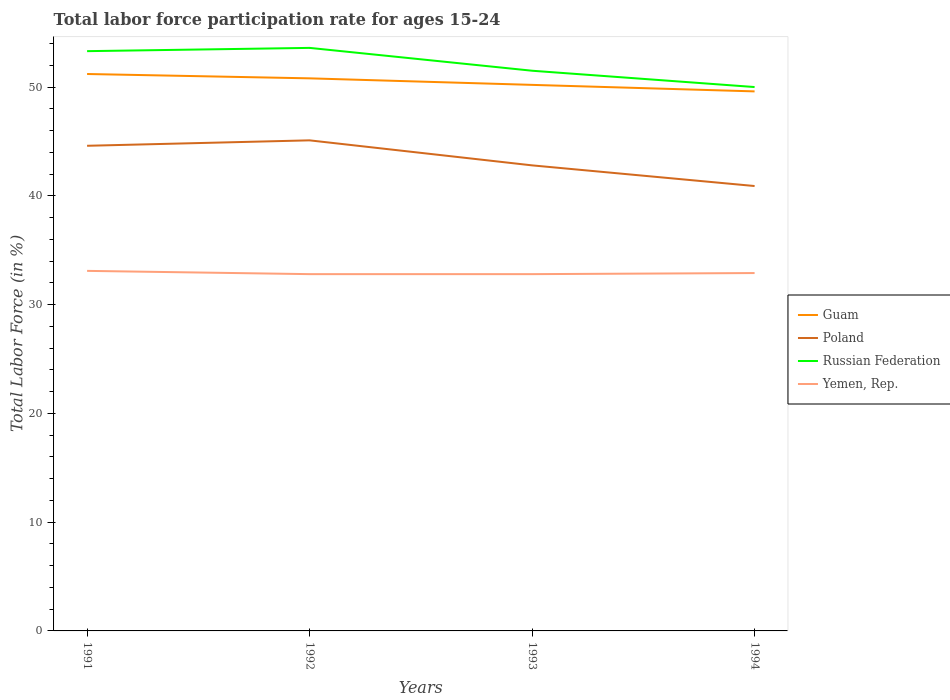How many different coloured lines are there?
Give a very brief answer. 4. Is the number of lines equal to the number of legend labels?
Your answer should be compact. Yes. Across all years, what is the maximum labor force participation rate in Poland?
Give a very brief answer. 40.9. In which year was the labor force participation rate in Russian Federation maximum?
Make the answer very short. 1994. What is the total labor force participation rate in Poland in the graph?
Make the answer very short. 1.8. What is the difference between the highest and the second highest labor force participation rate in Russian Federation?
Your answer should be compact. 3.6. Is the labor force participation rate in Guam strictly greater than the labor force participation rate in Russian Federation over the years?
Ensure brevity in your answer.  Yes. How many lines are there?
Provide a short and direct response. 4. Does the graph contain grids?
Ensure brevity in your answer.  No. How many legend labels are there?
Provide a short and direct response. 4. How are the legend labels stacked?
Keep it short and to the point. Vertical. What is the title of the graph?
Give a very brief answer. Total labor force participation rate for ages 15-24. Does "Latin America(developing only)" appear as one of the legend labels in the graph?
Keep it short and to the point. No. What is the label or title of the X-axis?
Give a very brief answer. Years. What is the label or title of the Y-axis?
Your answer should be compact. Total Labor Force (in %). What is the Total Labor Force (in %) of Guam in 1991?
Offer a very short reply. 51.2. What is the Total Labor Force (in %) in Poland in 1991?
Provide a succinct answer. 44.6. What is the Total Labor Force (in %) in Russian Federation in 1991?
Ensure brevity in your answer.  53.3. What is the Total Labor Force (in %) of Yemen, Rep. in 1991?
Ensure brevity in your answer.  33.1. What is the Total Labor Force (in %) in Guam in 1992?
Your answer should be compact. 50.8. What is the Total Labor Force (in %) in Poland in 1992?
Ensure brevity in your answer.  45.1. What is the Total Labor Force (in %) in Russian Federation in 1992?
Your answer should be very brief. 53.6. What is the Total Labor Force (in %) in Yemen, Rep. in 1992?
Ensure brevity in your answer.  32.8. What is the Total Labor Force (in %) of Guam in 1993?
Offer a very short reply. 50.2. What is the Total Labor Force (in %) in Poland in 1993?
Give a very brief answer. 42.8. What is the Total Labor Force (in %) of Russian Federation in 1993?
Keep it short and to the point. 51.5. What is the Total Labor Force (in %) of Yemen, Rep. in 1993?
Ensure brevity in your answer.  32.8. What is the Total Labor Force (in %) in Guam in 1994?
Offer a very short reply. 49.6. What is the Total Labor Force (in %) of Poland in 1994?
Provide a succinct answer. 40.9. What is the Total Labor Force (in %) in Russian Federation in 1994?
Your answer should be compact. 50. What is the Total Labor Force (in %) of Yemen, Rep. in 1994?
Give a very brief answer. 32.9. Across all years, what is the maximum Total Labor Force (in %) of Guam?
Your answer should be very brief. 51.2. Across all years, what is the maximum Total Labor Force (in %) in Poland?
Make the answer very short. 45.1. Across all years, what is the maximum Total Labor Force (in %) of Russian Federation?
Your answer should be very brief. 53.6. Across all years, what is the maximum Total Labor Force (in %) of Yemen, Rep.?
Keep it short and to the point. 33.1. Across all years, what is the minimum Total Labor Force (in %) in Guam?
Ensure brevity in your answer.  49.6. Across all years, what is the minimum Total Labor Force (in %) of Poland?
Keep it short and to the point. 40.9. Across all years, what is the minimum Total Labor Force (in %) in Yemen, Rep.?
Provide a succinct answer. 32.8. What is the total Total Labor Force (in %) in Guam in the graph?
Ensure brevity in your answer.  201.8. What is the total Total Labor Force (in %) of Poland in the graph?
Your answer should be very brief. 173.4. What is the total Total Labor Force (in %) of Russian Federation in the graph?
Keep it short and to the point. 208.4. What is the total Total Labor Force (in %) in Yemen, Rep. in the graph?
Your answer should be very brief. 131.6. What is the difference between the Total Labor Force (in %) of Poland in 1991 and that in 1993?
Offer a terse response. 1.8. What is the difference between the Total Labor Force (in %) of Guam in 1991 and that in 1994?
Offer a very short reply. 1.6. What is the difference between the Total Labor Force (in %) of Poland in 1991 and that in 1994?
Offer a terse response. 3.7. What is the difference between the Total Labor Force (in %) in Yemen, Rep. in 1991 and that in 1994?
Keep it short and to the point. 0.2. What is the difference between the Total Labor Force (in %) of Poland in 1992 and that in 1993?
Your answer should be compact. 2.3. What is the difference between the Total Labor Force (in %) of Poland in 1992 and that in 1994?
Offer a terse response. 4.2. What is the difference between the Total Labor Force (in %) in Russian Federation in 1992 and that in 1994?
Offer a very short reply. 3.6. What is the difference between the Total Labor Force (in %) of Yemen, Rep. in 1992 and that in 1994?
Make the answer very short. -0.1. What is the difference between the Total Labor Force (in %) of Russian Federation in 1993 and that in 1994?
Give a very brief answer. 1.5. What is the difference between the Total Labor Force (in %) of Poland in 1991 and the Total Labor Force (in %) of Russian Federation in 1992?
Keep it short and to the point. -9. What is the difference between the Total Labor Force (in %) in Guam in 1991 and the Total Labor Force (in %) in Russian Federation in 1993?
Offer a very short reply. -0.3. What is the difference between the Total Labor Force (in %) of Poland in 1991 and the Total Labor Force (in %) of Yemen, Rep. in 1993?
Ensure brevity in your answer.  11.8. What is the difference between the Total Labor Force (in %) in Guam in 1991 and the Total Labor Force (in %) in Russian Federation in 1994?
Ensure brevity in your answer.  1.2. What is the difference between the Total Labor Force (in %) of Guam in 1991 and the Total Labor Force (in %) of Yemen, Rep. in 1994?
Your answer should be compact. 18.3. What is the difference between the Total Labor Force (in %) in Poland in 1991 and the Total Labor Force (in %) in Russian Federation in 1994?
Your answer should be very brief. -5.4. What is the difference between the Total Labor Force (in %) of Russian Federation in 1991 and the Total Labor Force (in %) of Yemen, Rep. in 1994?
Provide a short and direct response. 20.4. What is the difference between the Total Labor Force (in %) of Guam in 1992 and the Total Labor Force (in %) of Poland in 1993?
Offer a very short reply. 8. What is the difference between the Total Labor Force (in %) in Russian Federation in 1992 and the Total Labor Force (in %) in Yemen, Rep. in 1993?
Your answer should be compact. 20.8. What is the difference between the Total Labor Force (in %) in Guam in 1992 and the Total Labor Force (in %) in Yemen, Rep. in 1994?
Offer a very short reply. 17.9. What is the difference between the Total Labor Force (in %) in Poland in 1992 and the Total Labor Force (in %) in Russian Federation in 1994?
Provide a short and direct response. -4.9. What is the difference between the Total Labor Force (in %) in Russian Federation in 1992 and the Total Labor Force (in %) in Yemen, Rep. in 1994?
Provide a short and direct response. 20.7. What is the difference between the Total Labor Force (in %) of Guam in 1993 and the Total Labor Force (in %) of Poland in 1994?
Make the answer very short. 9.3. What is the difference between the Total Labor Force (in %) in Guam in 1993 and the Total Labor Force (in %) in Yemen, Rep. in 1994?
Make the answer very short. 17.3. What is the difference between the Total Labor Force (in %) of Poland in 1993 and the Total Labor Force (in %) of Russian Federation in 1994?
Keep it short and to the point. -7.2. What is the difference between the Total Labor Force (in %) of Russian Federation in 1993 and the Total Labor Force (in %) of Yemen, Rep. in 1994?
Offer a terse response. 18.6. What is the average Total Labor Force (in %) in Guam per year?
Ensure brevity in your answer.  50.45. What is the average Total Labor Force (in %) in Poland per year?
Provide a short and direct response. 43.35. What is the average Total Labor Force (in %) of Russian Federation per year?
Give a very brief answer. 52.1. What is the average Total Labor Force (in %) of Yemen, Rep. per year?
Provide a succinct answer. 32.9. In the year 1991, what is the difference between the Total Labor Force (in %) in Guam and Total Labor Force (in %) in Yemen, Rep.?
Give a very brief answer. 18.1. In the year 1991, what is the difference between the Total Labor Force (in %) of Poland and Total Labor Force (in %) of Russian Federation?
Your answer should be very brief. -8.7. In the year 1991, what is the difference between the Total Labor Force (in %) of Russian Federation and Total Labor Force (in %) of Yemen, Rep.?
Offer a very short reply. 20.2. In the year 1992, what is the difference between the Total Labor Force (in %) of Guam and Total Labor Force (in %) of Poland?
Offer a very short reply. 5.7. In the year 1992, what is the difference between the Total Labor Force (in %) in Guam and Total Labor Force (in %) in Russian Federation?
Offer a terse response. -2.8. In the year 1992, what is the difference between the Total Labor Force (in %) in Poland and Total Labor Force (in %) in Yemen, Rep.?
Offer a terse response. 12.3. In the year 1992, what is the difference between the Total Labor Force (in %) in Russian Federation and Total Labor Force (in %) in Yemen, Rep.?
Keep it short and to the point. 20.8. In the year 1993, what is the difference between the Total Labor Force (in %) in Guam and Total Labor Force (in %) in Yemen, Rep.?
Keep it short and to the point. 17.4. In the year 1993, what is the difference between the Total Labor Force (in %) of Russian Federation and Total Labor Force (in %) of Yemen, Rep.?
Your answer should be very brief. 18.7. In the year 1994, what is the difference between the Total Labor Force (in %) of Guam and Total Labor Force (in %) of Russian Federation?
Give a very brief answer. -0.4. In the year 1994, what is the difference between the Total Labor Force (in %) of Guam and Total Labor Force (in %) of Yemen, Rep.?
Your answer should be compact. 16.7. What is the ratio of the Total Labor Force (in %) in Guam in 1991 to that in 1992?
Give a very brief answer. 1.01. What is the ratio of the Total Labor Force (in %) of Poland in 1991 to that in 1992?
Keep it short and to the point. 0.99. What is the ratio of the Total Labor Force (in %) of Russian Federation in 1991 to that in 1992?
Your answer should be very brief. 0.99. What is the ratio of the Total Labor Force (in %) in Yemen, Rep. in 1991 to that in 1992?
Make the answer very short. 1.01. What is the ratio of the Total Labor Force (in %) of Guam in 1991 to that in 1993?
Provide a succinct answer. 1.02. What is the ratio of the Total Labor Force (in %) in Poland in 1991 to that in 1993?
Your answer should be compact. 1.04. What is the ratio of the Total Labor Force (in %) of Russian Federation in 1991 to that in 1993?
Your answer should be compact. 1.03. What is the ratio of the Total Labor Force (in %) of Yemen, Rep. in 1991 to that in 1993?
Keep it short and to the point. 1.01. What is the ratio of the Total Labor Force (in %) in Guam in 1991 to that in 1994?
Your answer should be compact. 1.03. What is the ratio of the Total Labor Force (in %) in Poland in 1991 to that in 1994?
Offer a very short reply. 1.09. What is the ratio of the Total Labor Force (in %) in Russian Federation in 1991 to that in 1994?
Make the answer very short. 1.07. What is the ratio of the Total Labor Force (in %) in Guam in 1992 to that in 1993?
Keep it short and to the point. 1.01. What is the ratio of the Total Labor Force (in %) in Poland in 1992 to that in 1993?
Your response must be concise. 1.05. What is the ratio of the Total Labor Force (in %) in Russian Federation in 1992 to that in 1993?
Keep it short and to the point. 1.04. What is the ratio of the Total Labor Force (in %) of Guam in 1992 to that in 1994?
Your answer should be very brief. 1.02. What is the ratio of the Total Labor Force (in %) of Poland in 1992 to that in 1994?
Provide a succinct answer. 1.1. What is the ratio of the Total Labor Force (in %) of Russian Federation in 1992 to that in 1994?
Your answer should be compact. 1.07. What is the ratio of the Total Labor Force (in %) of Guam in 1993 to that in 1994?
Keep it short and to the point. 1.01. What is the ratio of the Total Labor Force (in %) in Poland in 1993 to that in 1994?
Make the answer very short. 1.05. What is the difference between the highest and the second highest Total Labor Force (in %) in Russian Federation?
Offer a very short reply. 0.3. What is the difference between the highest and the lowest Total Labor Force (in %) in Guam?
Keep it short and to the point. 1.6. What is the difference between the highest and the lowest Total Labor Force (in %) in Russian Federation?
Offer a very short reply. 3.6. What is the difference between the highest and the lowest Total Labor Force (in %) of Yemen, Rep.?
Your answer should be very brief. 0.3. 